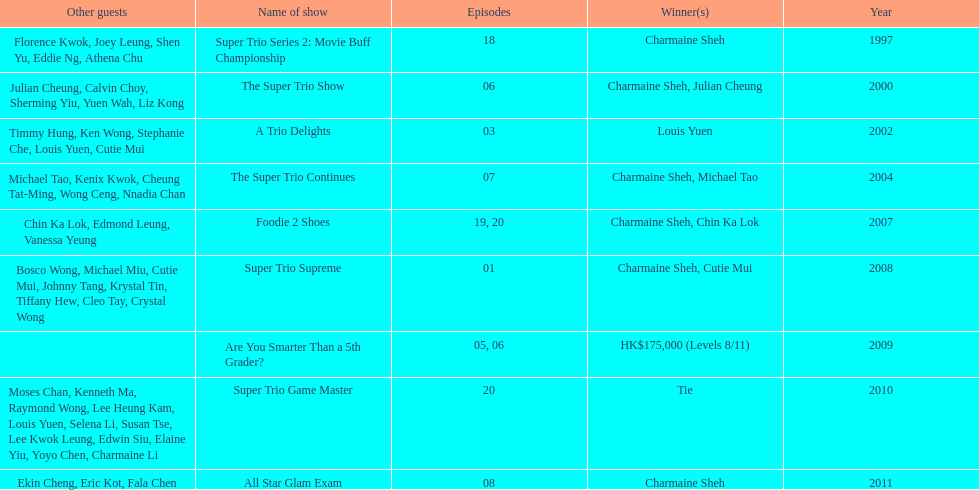How many episodes was charmaine sheh on in the variety show super trio 2: movie buff champions 18. 